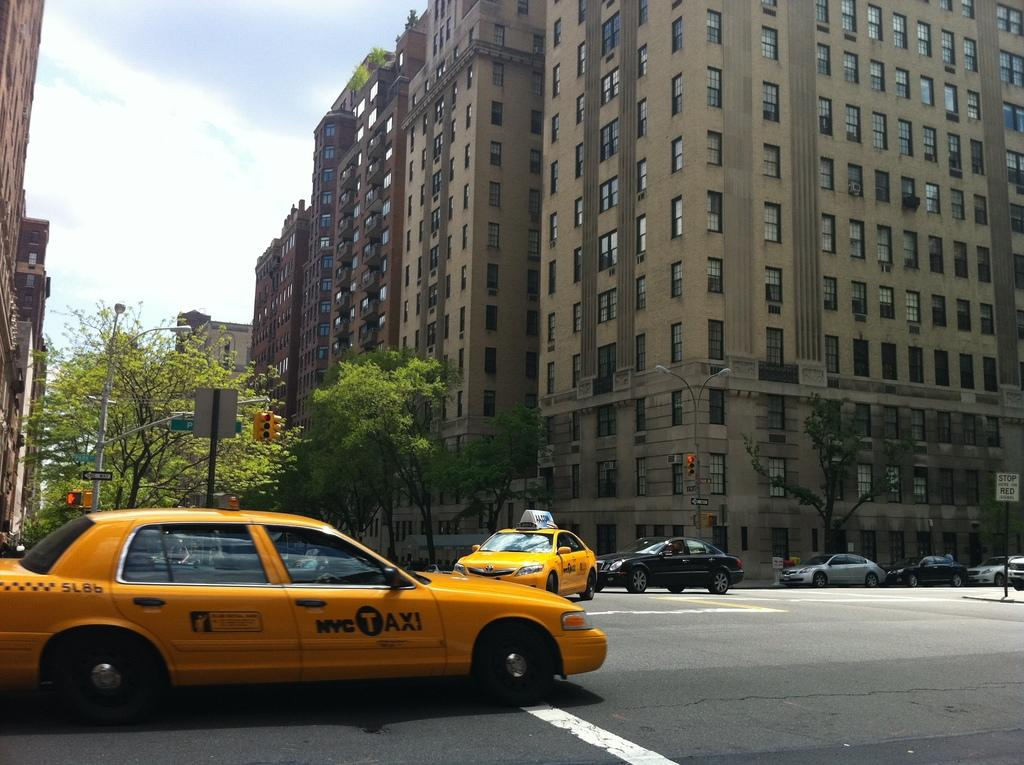<image>
Create a compact narrative representing the image presented. Yellow cab that says NYC Taxi on it in a town. 